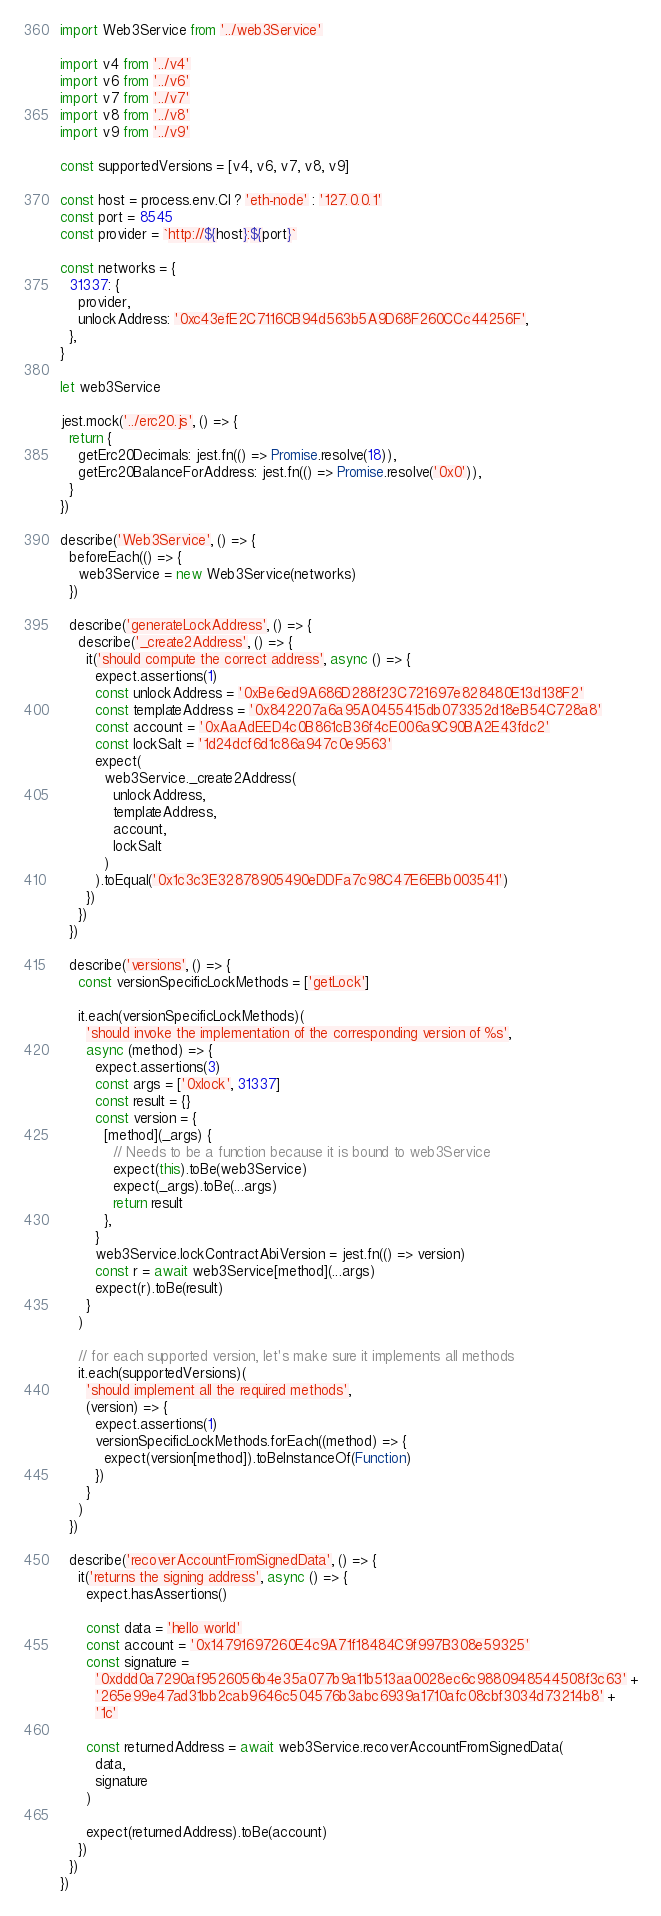Convert code to text. <code><loc_0><loc_0><loc_500><loc_500><_JavaScript_>import Web3Service from '../web3Service'

import v4 from '../v4'
import v6 from '../v6'
import v7 from '../v7'
import v8 from '../v8'
import v9 from '../v9'

const supportedVersions = [v4, v6, v7, v8, v9]

const host = process.env.CI ? 'eth-node' : '127.0.0.1'
const port = 8545
const provider = `http://${host}:${port}`

const networks = {
  31337: {
    provider,
    unlockAddress: '0xc43efE2C7116CB94d563b5A9D68F260CCc44256F',
  },
}

let web3Service

jest.mock('../erc20.js', () => {
  return {
    getErc20Decimals: jest.fn(() => Promise.resolve(18)),
    getErc20BalanceForAddress: jest.fn(() => Promise.resolve('0x0')),
  }
})

describe('Web3Service', () => {
  beforeEach(() => {
    web3Service = new Web3Service(networks)
  })

  describe('generateLockAddress', () => {
    describe('_create2Address', () => {
      it('should compute the correct address', async () => {
        expect.assertions(1)
        const unlockAddress = '0xBe6ed9A686D288f23C721697e828480E13d138F2'
        const templateAddress = '0x842207a6a95A0455415db073352d18eB54C728a8'
        const account = '0xAaAdEED4c0B861cB36f4cE006a9C90BA2E43fdc2'
        const lockSalt = '1d24dcf6d1c86a947c0e9563'
        expect(
          web3Service._create2Address(
            unlockAddress,
            templateAddress,
            account,
            lockSalt
          )
        ).toEqual('0x1c3c3E32878905490eDDFa7c98C47E6EBb003541')
      })
    })
  })

  describe('versions', () => {
    const versionSpecificLockMethods = ['getLock']

    it.each(versionSpecificLockMethods)(
      'should invoke the implementation of the corresponding version of %s',
      async (method) => {
        expect.assertions(3)
        const args = ['0xlock', 31337]
        const result = {}
        const version = {
          [method](_args) {
            // Needs to be a function because it is bound to web3Service
            expect(this).toBe(web3Service)
            expect(_args).toBe(...args)
            return result
          },
        }
        web3Service.lockContractAbiVersion = jest.fn(() => version)
        const r = await web3Service[method](...args)
        expect(r).toBe(result)
      }
    )

    // for each supported version, let's make sure it implements all methods
    it.each(supportedVersions)(
      'should implement all the required methods',
      (version) => {
        expect.assertions(1)
        versionSpecificLockMethods.forEach((method) => {
          expect(version[method]).toBeInstanceOf(Function)
        })
      }
    )
  })

  describe('recoverAccountFromSignedData', () => {
    it('returns the signing address', async () => {
      expect.hasAssertions()

      const data = 'hello world'
      const account = '0x14791697260E4c9A71f18484C9f997B308e59325'
      const signature =
        '0xddd0a7290af9526056b4e35a077b9a11b513aa0028ec6c9880948544508f3c63' +
        '265e99e47ad31bb2cab9646c504576b3abc6939a1710afc08cbf3034d73214b8' +
        '1c'

      const returnedAddress = await web3Service.recoverAccountFromSignedData(
        data,
        signature
      )

      expect(returnedAddress).toBe(account)
    })
  })
})
</code> 